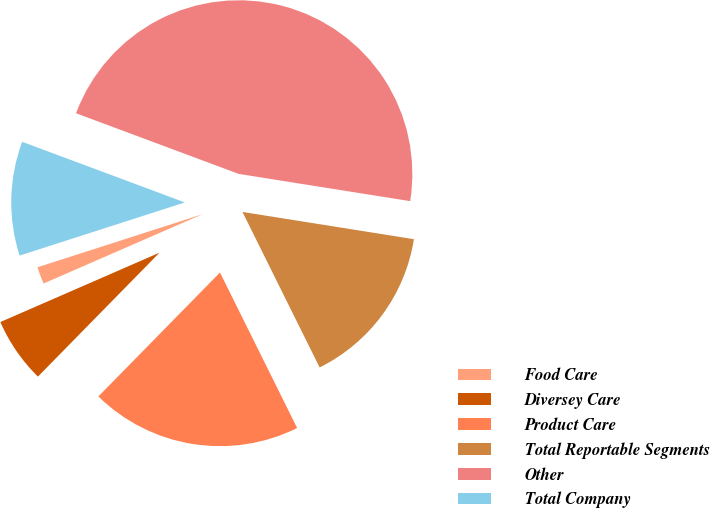Convert chart. <chart><loc_0><loc_0><loc_500><loc_500><pie_chart><fcel>Food Care<fcel>Diversey Care<fcel>Product Care<fcel>Total Reportable Segments<fcel>Other<fcel>Total Company<nl><fcel>1.59%<fcel>6.11%<fcel>19.68%<fcel>15.16%<fcel>46.83%<fcel>10.63%<nl></chart> 